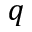Convert formula to latex. <formula><loc_0><loc_0><loc_500><loc_500>q</formula> 